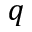Convert formula to latex. <formula><loc_0><loc_0><loc_500><loc_500>q</formula> 